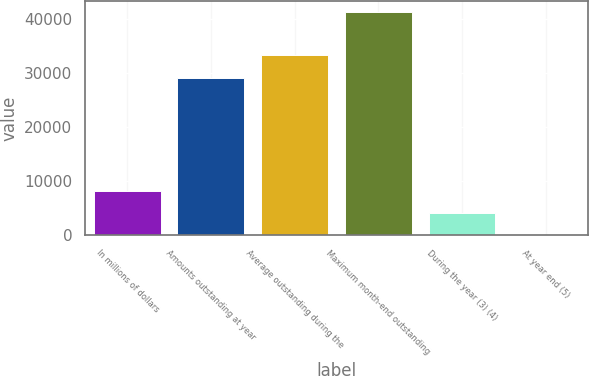<chart> <loc_0><loc_0><loc_500><loc_500><bar_chart><fcel>In millions of dollars<fcel>Amounts outstanding at year<fcel>Average outstanding during the<fcel>Maximum month-end outstanding<fcel>During the year (3) (4)<fcel>At year end (5)<nl><fcel>8243.73<fcel>29125<fcel>33246<fcel>41212<fcel>4122.7<fcel>1.67<nl></chart> 